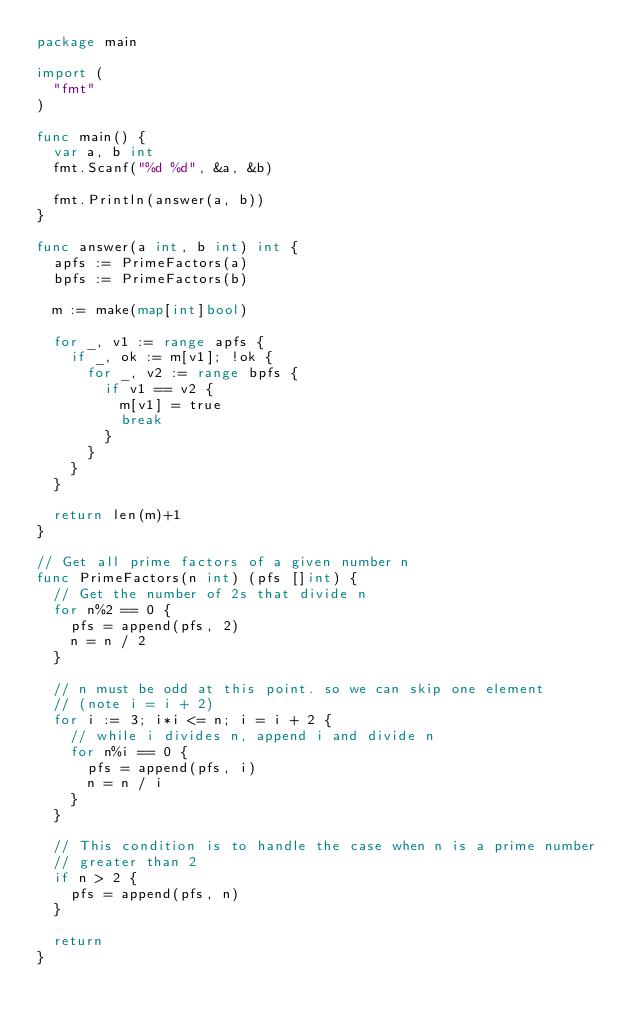<code> <loc_0><loc_0><loc_500><loc_500><_Go_>package main

import (
	"fmt"
)

func main() {
	var a, b int
	fmt.Scanf("%d %d", &a, &b)

	fmt.Println(answer(a, b))
}

func answer(a int, b int) int {
	apfs := PrimeFactors(a)
	bpfs := PrimeFactors(b)

	m := make(map[int]bool)

	for _, v1 := range apfs {
		if _, ok := m[v1]; !ok {
			for _, v2 := range bpfs {
				if v1 == v2 {
					m[v1] = true
					break
				}
			}
		}
	}

	return len(m)+1
}

// Get all prime factors of a given number n
func PrimeFactors(n int) (pfs []int) {
	// Get the number of 2s that divide n
	for n%2 == 0 {
		pfs = append(pfs, 2)
		n = n / 2
	}

	// n must be odd at this point. so we can skip one element
	// (note i = i + 2)
	for i := 3; i*i <= n; i = i + 2 {
		// while i divides n, append i and divide n
		for n%i == 0 {
			pfs = append(pfs, i)
			n = n / i
		}
	}

	// This condition is to handle the case when n is a prime number
	// greater than 2
	if n > 2 {
		pfs = append(pfs, n)
	}

	return
}</code> 